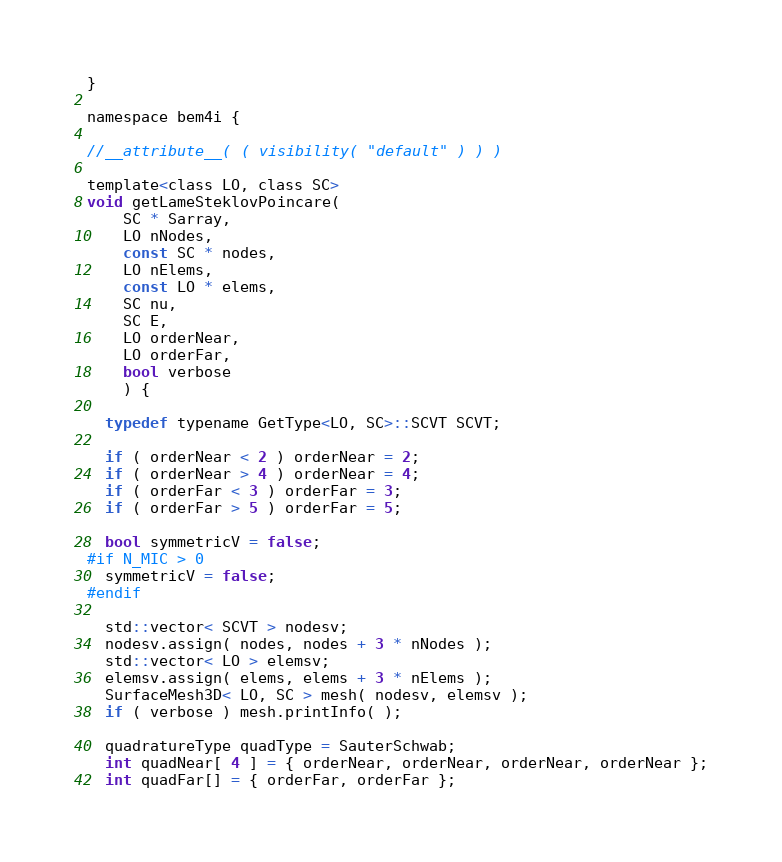Convert code to text. <code><loc_0><loc_0><loc_500><loc_500><_C_>}

namespace bem4i {

//__attribute__( ( visibility( "default" ) ) )

template<class LO, class SC>
void getLameSteklovPoincare(
    SC * Sarray,
    LO nNodes,
    const SC * nodes,
    LO nElems,
    const LO * elems,
    SC nu,
    SC E,
    LO orderNear,
    LO orderFar,
    bool verbose
    ) {

  typedef typename GetType<LO, SC>::SCVT SCVT;

  if ( orderNear < 2 ) orderNear = 2;
  if ( orderNear > 4 ) orderNear = 4;
  if ( orderFar < 3 ) orderFar = 3;
  if ( orderFar > 5 ) orderFar = 5;

  bool symmetricV = false;
#if N_MIC > 0
  symmetricV = false;
#endif

  std::vector< SCVT > nodesv;
  nodesv.assign( nodes, nodes + 3 * nNodes );
  std::vector< LO > elemsv;
  elemsv.assign( elems, elems + 3 * nElems );
  SurfaceMesh3D< LO, SC > mesh( nodesv, elemsv );
  if ( verbose ) mesh.printInfo( );

  quadratureType quadType = SauterSchwab;
  int quadNear[ 4 ] = { orderNear, orderNear, orderNear, orderNear };
  int quadFar[] = { orderFar, orderFar };</code> 